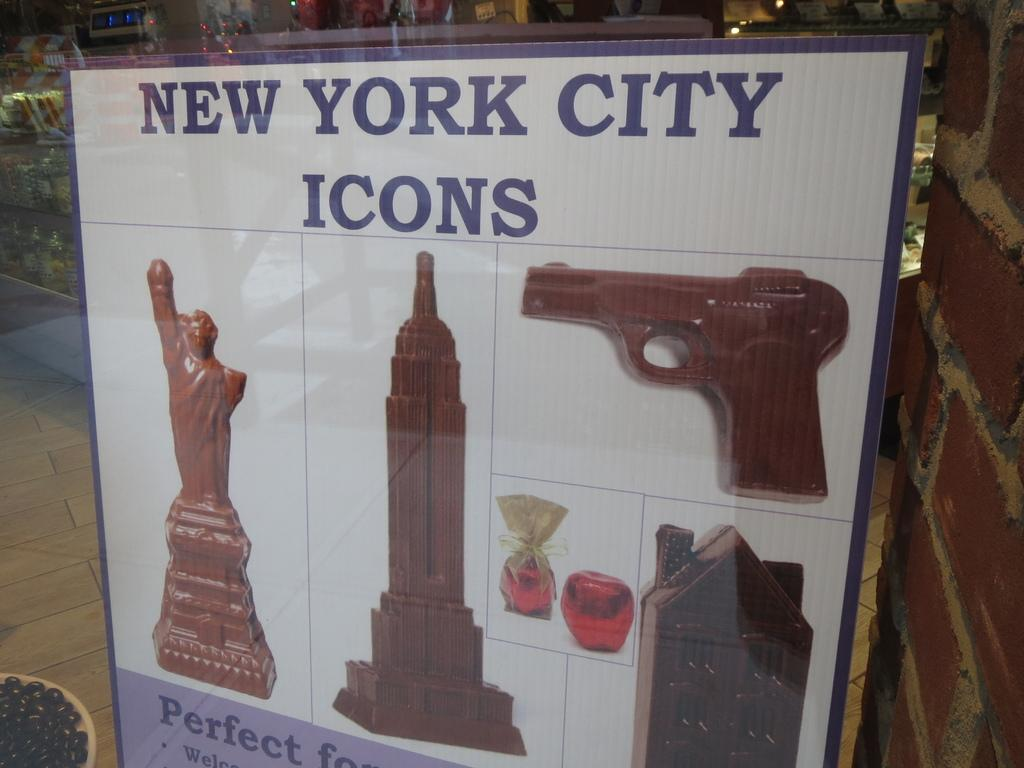Provide a one-sentence caption for the provided image. A poster in a shop window shows chocolate shapes of a gun and buildings under the heading New York City Icons. 